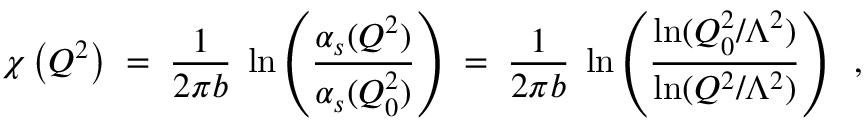<formula> <loc_0><loc_0><loc_500><loc_500>\chi \left ( Q ^ { 2 } \right ) \, = \, \frac { 1 } { 2 \pi b } \, \ln \left ( \frac { \alpha _ { s } ( Q ^ { 2 } ) } { \alpha _ { s } ( Q _ { 0 } ^ { 2 } ) } \right ) \, = \, \frac { 1 } { 2 \pi b } \, \ln \left ( \frac { \ln ( Q _ { 0 } ^ { 2 } / \Lambda ^ { 2 } ) } { \ln ( Q ^ { 2 } / \Lambda ^ { 2 } ) } \right ) \, ,</formula> 